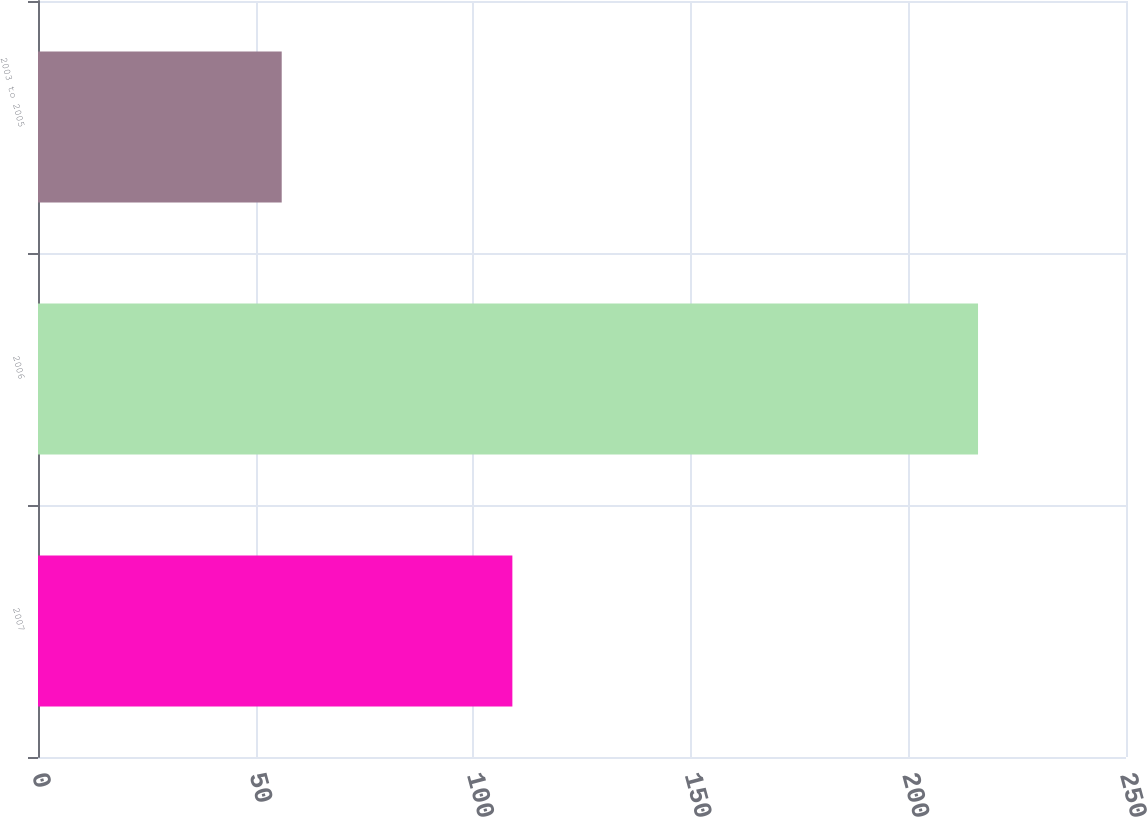Convert chart to OTSL. <chart><loc_0><loc_0><loc_500><loc_500><bar_chart><fcel>2007<fcel>2006<fcel>2003 to 2005<nl><fcel>109<fcel>216<fcel>56<nl></chart> 